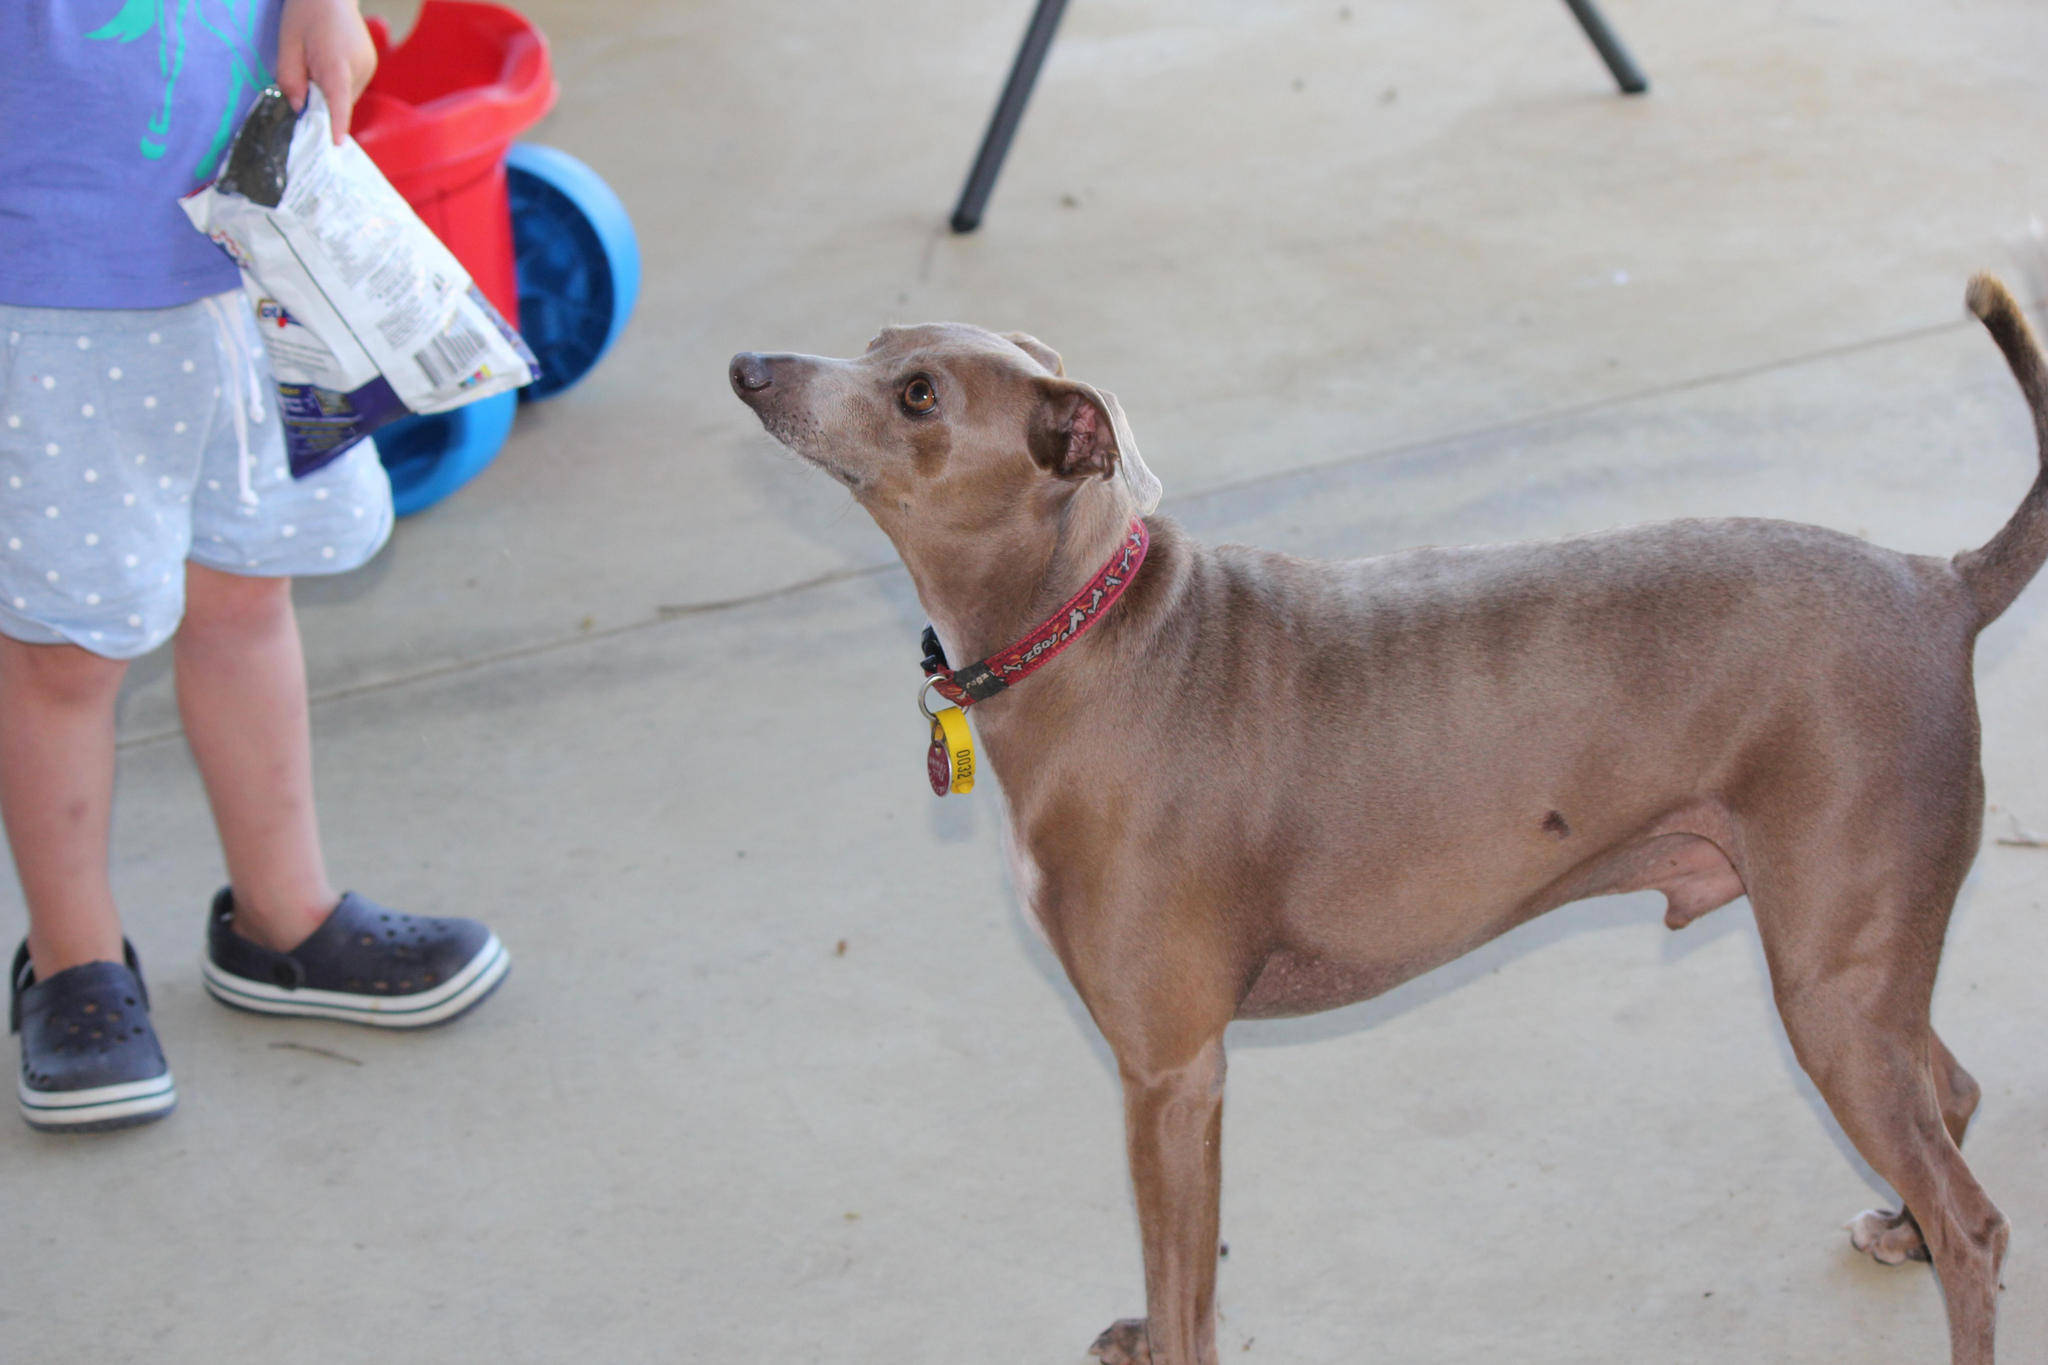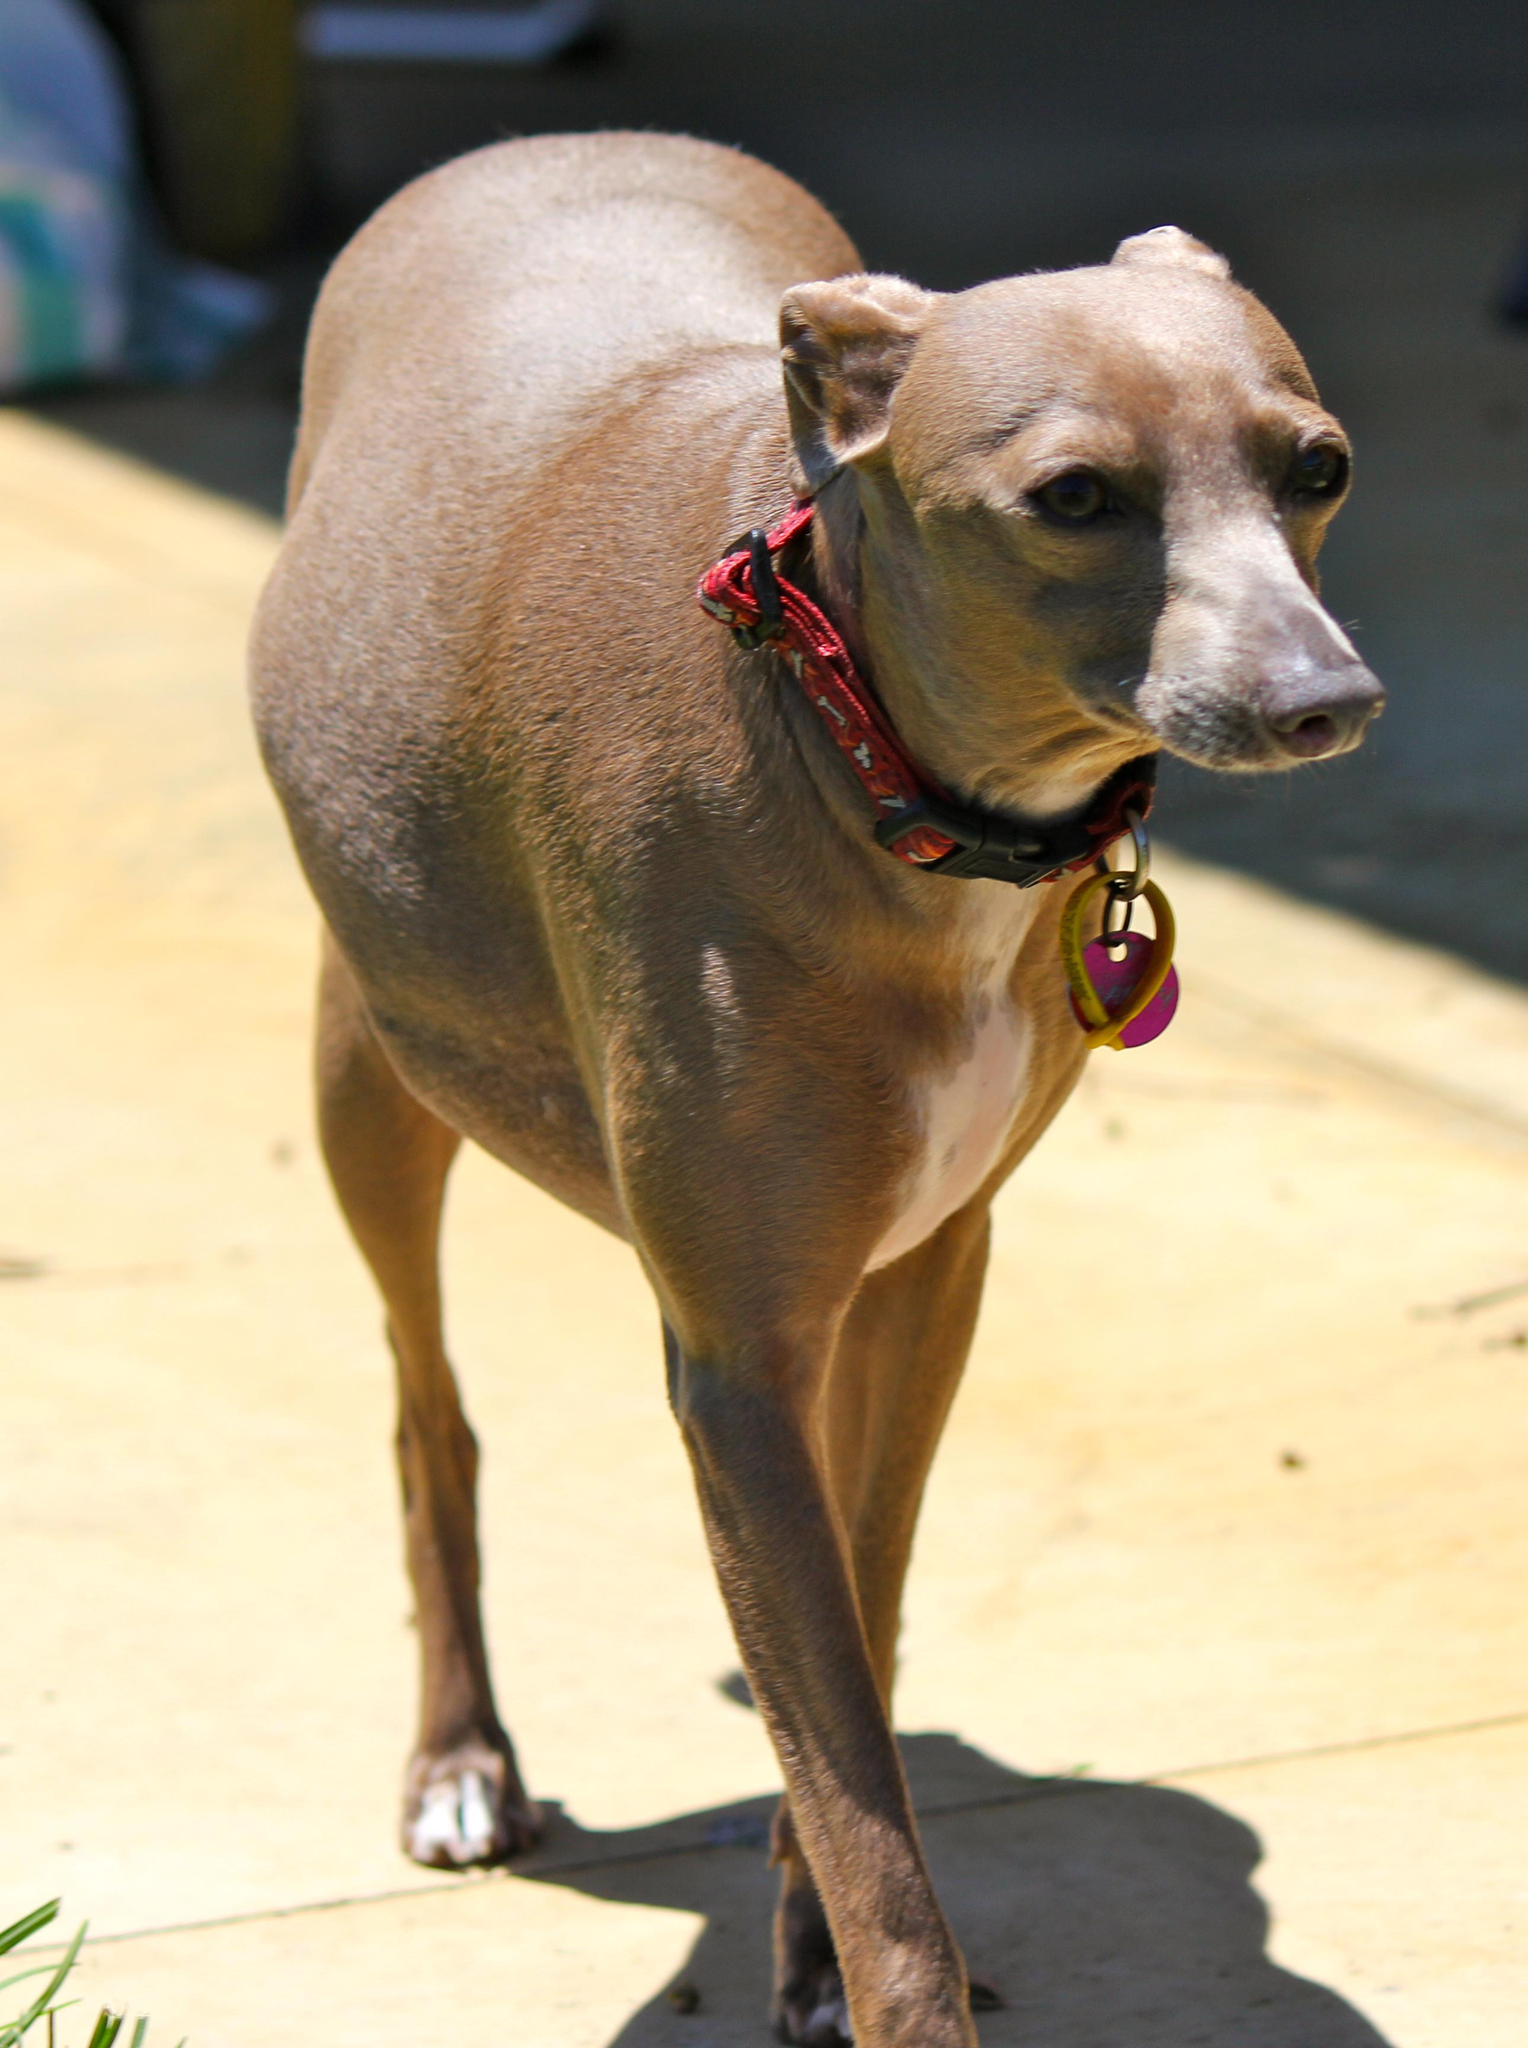The first image is the image on the left, the second image is the image on the right. Assess this claim about the two images: "the dog in the image on the left is standing on grass". Correct or not? Answer yes or no. No. The first image is the image on the left, the second image is the image on the right. Considering the images on both sides, is "Left image shows a dog standing on green grass." valid? Answer yes or no. No. 